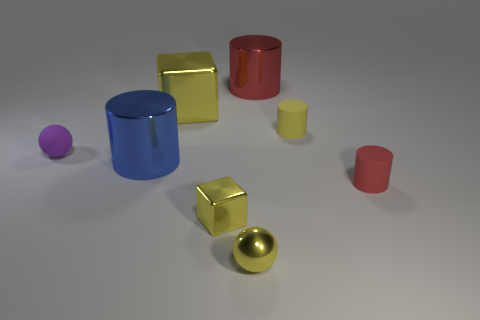What is the shape of the yellow metallic object that is the same size as the yellow sphere? The yellow metallic object of similar size to the yellow sphere is a cube. It has a gleaming surface that reflects light consistently across its six equal square faces. 